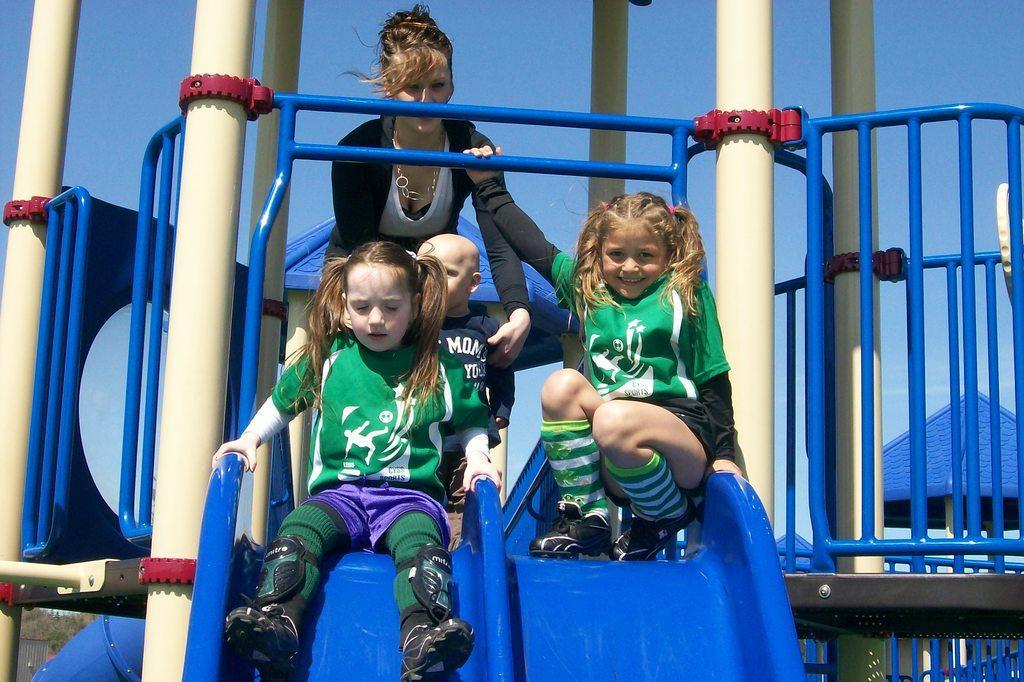Can you describe this image briefly? In this image we can see a few people on the sliders, there are some poles, grille and tents, in the background we can see the sky. 